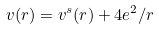Convert formula to latex. <formula><loc_0><loc_0><loc_500><loc_500>v ( r ) = v ^ { s } ( r ) + 4 e ^ { 2 } / r</formula> 